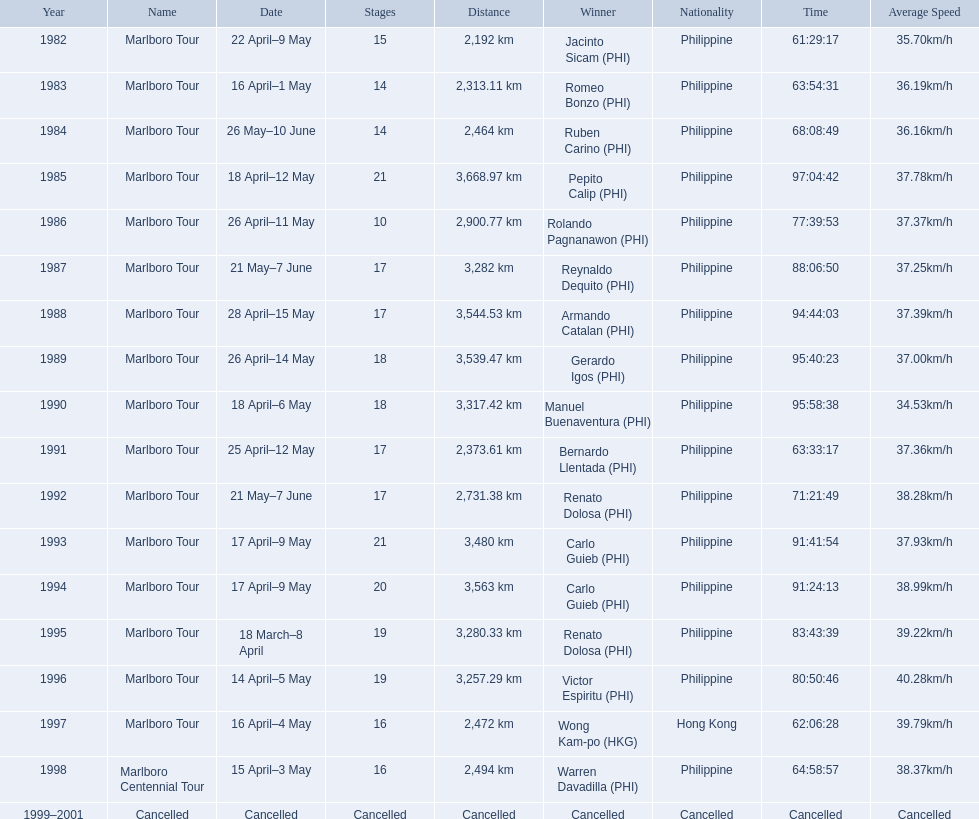What are the distances travelled on the tour? 2,192 km, 2,313.11 km, 2,464 km, 3,668.97 km, 2,900.77 km, 3,282 km, 3,544.53 km, 3,539.47 km, 3,317.42 km, 2,373.61 km, 2,731.38 km, 3,480 km, 3,563 km, 3,280.33 km, 3,257.29 km, 2,472 km, 2,494 km. Which of these are the largest? 3,668.97 km. 